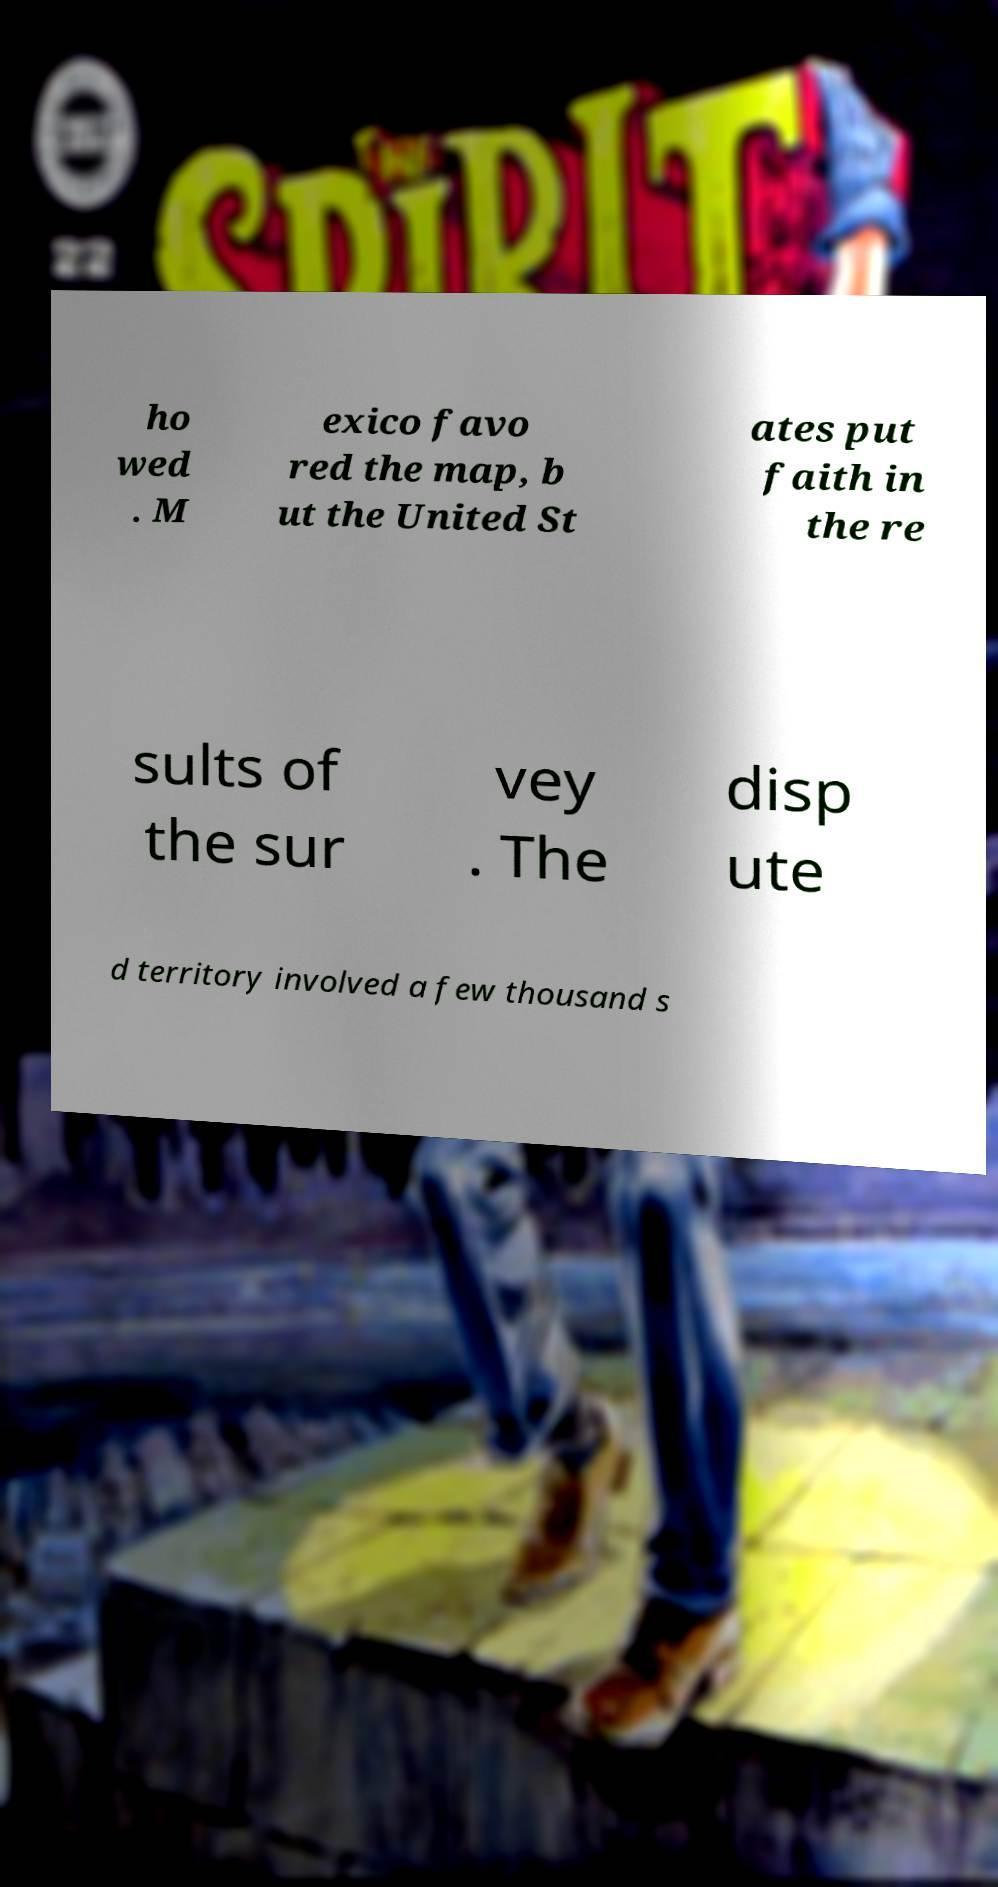Please read and relay the text visible in this image. What does it say? ho wed . M exico favo red the map, b ut the United St ates put faith in the re sults of the sur vey . The disp ute d territory involved a few thousand s 